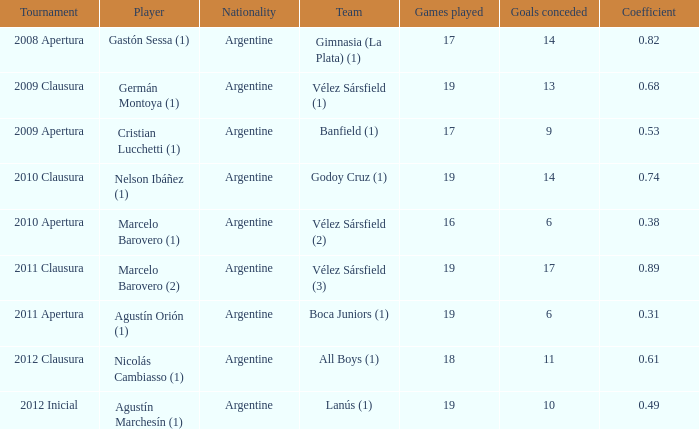What is the count of nationalities for the 2011 apertura? 1.0. 